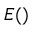Convert formula to latex. <formula><loc_0><loc_0><loc_500><loc_500>E ( )</formula> 